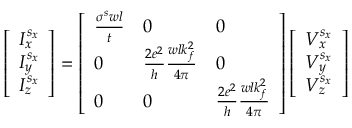<formula> <loc_0><loc_0><loc_500><loc_500>\left [ \begin{array} { l } { I _ { x } ^ { s _ { x } } } \\ { I _ { y } ^ { s _ { x } } } \\ { I _ { z } ^ { s _ { x } } } \end{array} \right ] = \left [ \begin{array} { l l l } { \frac { \sigma ^ { s } w l } { t } } & { 0 } & { 0 } \\ { 0 } & { \frac { 2 e ^ { 2 } } { h } \frac { w l k _ { f } ^ { 2 } } { 4 \pi } } & { 0 } \\ { 0 } & { 0 } & { \frac { 2 e ^ { 2 } } { h } \frac { w l k _ { f } ^ { 2 } } { 4 \pi } } \end{array} \right ] \left [ \begin{array} { l } { V _ { x } ^ { s _ { x } } } \\ { V _ { y } ^ { s _ { x } } } \\ { V _ { z } ^ { s _ { x } } } \end{array} \right ]</formula> 